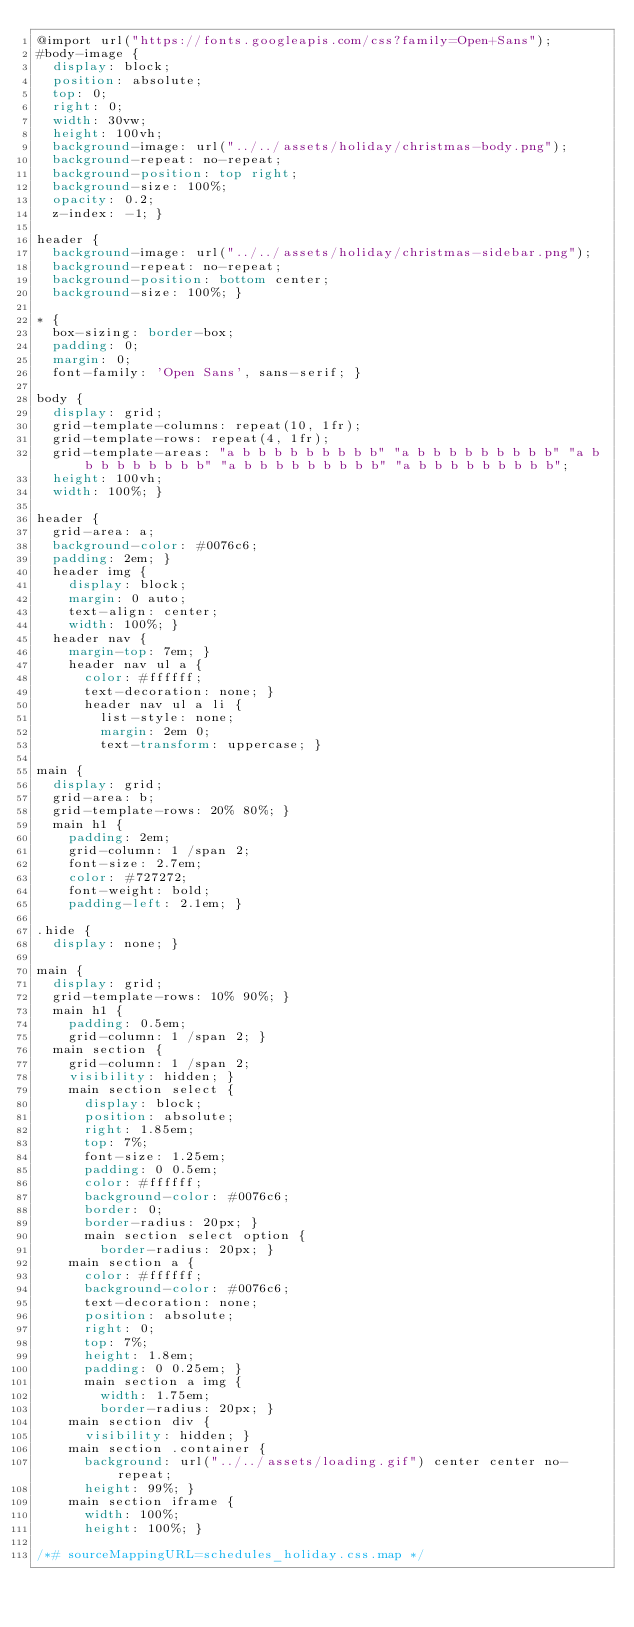Convert code to text. <code><loc_0><loc_0><loc_500><loc_500><_CSS_>@import url("https://fonts.googleapis.com/css?family=Open+Sans");
#body-image {
  display: block;
  position: absolute;
  top: 0;
  right: 0;
  width: 30vw;
  height: 100vh;
  background-image: url("../../assets/holiday/christmas-body.png");
  background-repeat: no-repeat;
  background-position: top right;
  background-size: 100%;
  opacity: 0.2;
  z-index: -1; }

header {
  background-image: url("../../assets/holiday/christmas-sidebar.png");
  background-repeat: no-repeat;
  background-position: bottom center;
  background-size: 100%; }

* {
  box-sizing: border-box;
  padding: 0;
  margin: 0;
  font-family: 'Open Sans', sans-serif; }

body {
  display: grid;
  grid-template-columns: repeat(10, 1fr);
  grid-template-rows: repeat(4, 1fr);
  grid-template-areas: "a b b b b b b b b b" "a b b b b b b b b b" "a b b b b b b b b b" "a b b b b b b b b b" "a b b b b b b b b b";
  height: 100vh;
  width: 100%; }

header {
  grid-area: a;
  background-color: #0076c6;
  padding: 2em; }
  header img {
    display: block;
    margin: 0 auto;
    text-align: center;
    width: 100%; }
  header nav {
    margin-top: 7em; }
    header nav ul a {
      color: #ffffff;
      text-decoration: none; }
      header nav ul a li {
        list-style: none;
        margin: 2em 0;
        text-transform: uppercase; }

main {
  display: grid;
  grid-area: b;
  grid-template-rows: 20% 80%; }
  main h1 {
    padding: 2em;
    grid-column: 1 /span 2;
    font-size: 2.7em;
    color: #727272;
    font-weight: bold;
    padding-left: 2.1em; }

.hide {
  display: none; }

main {
  display: grid;
  grid-template-rows: 10% 90%; }
  main h1 {
    padding: 0.5em;
    grid-column: 1 /span 2; }
  main section {
    grid-column: 1 /span 2;
    visibility: hidden; }
    main section select {
      display: block;
      position: absolute;
      right: 1.85em;
      top: 7%;
      font-size: 1.25em;
      padding: 0 0.5em;
      color: #ffffff;
      background-color: #0076c6;
      border: 0;
      border-radius: 20px; }
      main section select option {
        border-radius: 20px; }
    main section a {
      color: #ffffff;
      background-color: #0076c6;
      text-decoration: none;
      position: absolute;
      right: 0;
      top: 7%;
      height: 1.8em;
      padding: 0 0.25em; }
      main section a img {
        width: 1.75em;
        border-radius: 20px; }
    main section div {
      visibility: hidden; }
    main section .container {
      background: url("../../assets/loading.gif") center center no-repeat;
      height: 99%; }
    main section iframe {
      width: 100%;
      height: 100%; }

/*# sourceMappingURL=schedules_holiday.css.map */
</code> 